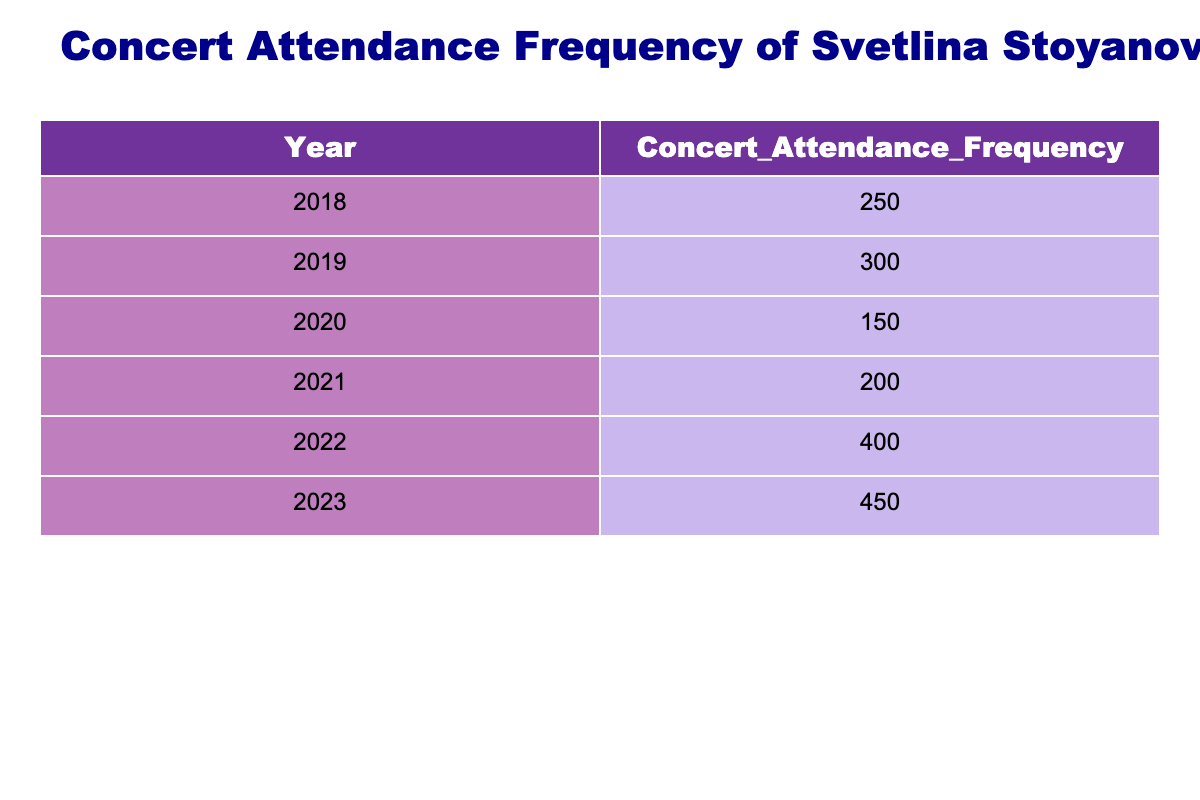What was the concert attendance frequency in 2021? The table indicates that the concert attendance frequency for the year 2021 is listed directly as 200.
Answer: 200 Which year had the highest concert attendance frequency? By examining the table, the year with the highest concert attendance frequency is 2023, with a frequency of 450.
Answer: 2023 What is the sum of concert attendance frequency from 2018 to 2020? We take the attendance frequencies for 2018 (250), 2019 (300), and 2020 (150), and sum them up: 250 + 300 + 150 = 700.
Answer: 700 Did concert attendance frequency increase every year from 2018 to 2023? Analyzing the table, the frequency decreased from 2019 to 2020 (300 to 150), indicating it did not strictly increase each year.
Answer: No What is the average concert attendance frequency from 2018 to 2023? The total attendance frequencies from 2018 to 2023 are 250 + 300 + 150 + 200 + 400 + 450 = 1750. Since there are 6 years, the average is 1750 / 6, which equals approximately 291.67.
Answer: 291.67 How much more was the concert attendance frequency in 2022 compared to 2020? The attendance frequency for 2022 is 400, while for 2020 it is 150. The difference is calculated as 400 - 150 = 250.
Answer: 250 What was the concert attendance frequency in the year with the second highest attendance? The highest attendance frequency is in 2023 (450), and the second highest is in 2022 (400) directly evident in the table.
Answer: 400 Was there a decrease in concert attendance frequency from 2021 to 2022? From the table, the attendance frequency increased from 200 in 2021 to 400 in 2022, showing no decrease.
Answer: No 